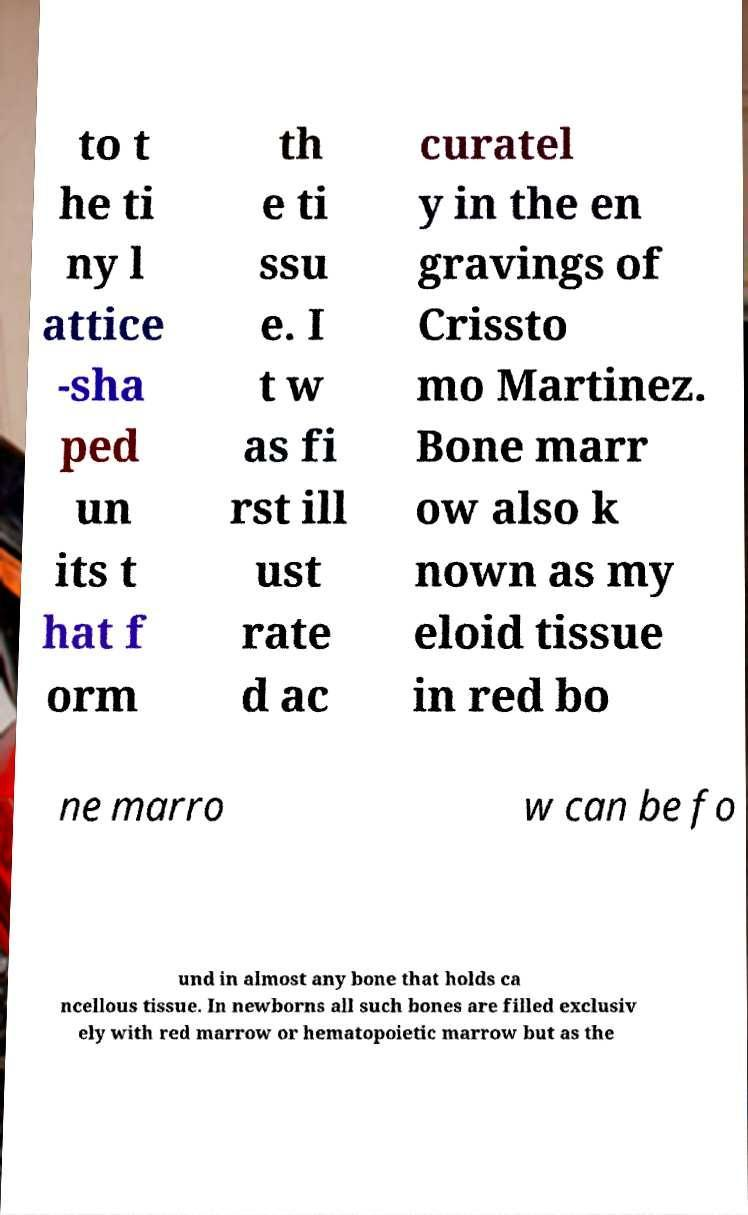For documentation purposes, I need the text within this image transcribed. Could you provide that? to t he ti ny l attice -sha ped un its t hat f orm th e ti ssu e. I t w as fi rst ill ust rate d ac curatel y in the en gravings of Crissto mo Martinez. Bone marr ow also k nown as my eloid tissue in red bo ne marro w can be fo und in almost any bone that holds ca ncellous tissue. In newborns all such bones are filled exclusiv ely with red marrow or hematopoietic marrow but as the 